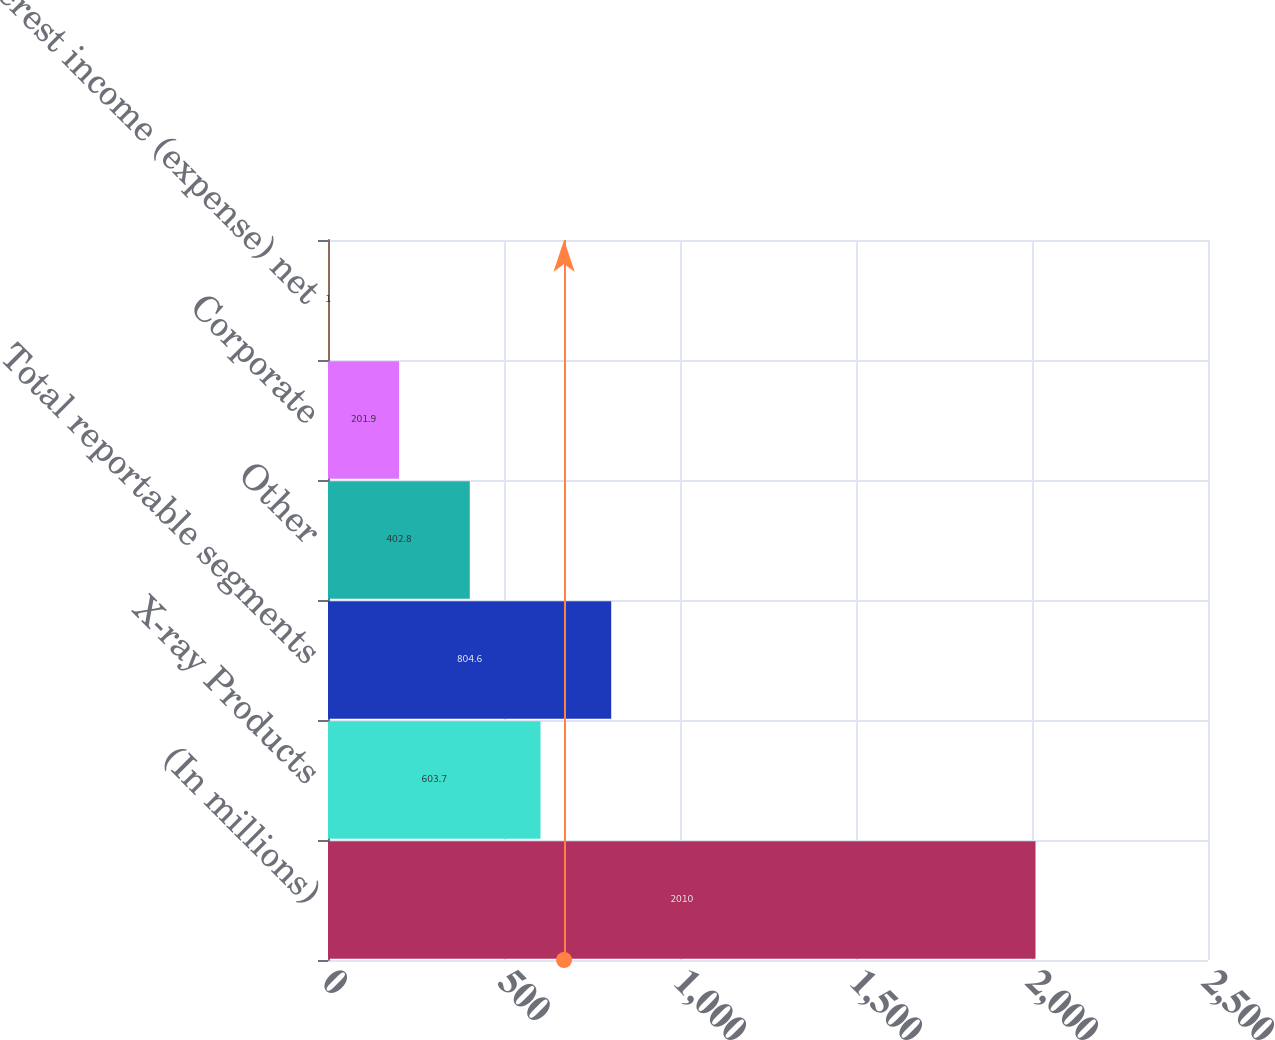<chart> <loc_0><loc_0><loc_500><loc_500><bar_chart><fcel>(In millions)<fcel>X-ray Products<fcel>Total reportable segments<fcel>Other<fcel>Corporate<fcel>Interest income (expense) net<nl><fcel>2010<fcel>603.7<fcel>804.6<fcel>402.8<fcel>201.9<fcel>1<nl></chart> 